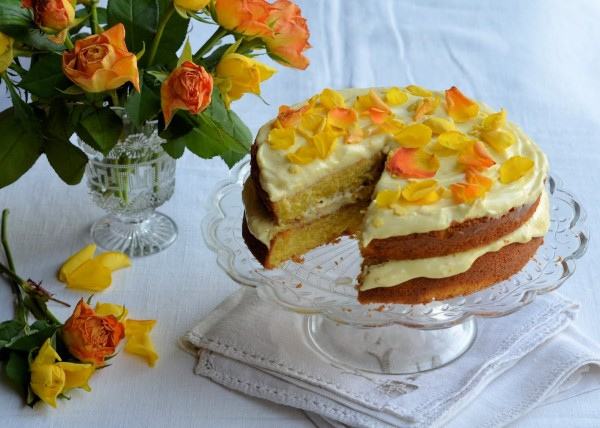<image>What event are the people celebrating? It's unclear what event the people are celebrating. It could be a wedding, birthday, or anniversary. What event are the people celebrating? I don't know what event the people are celebrating. It could be a wedding, birthday, or anniversary. 